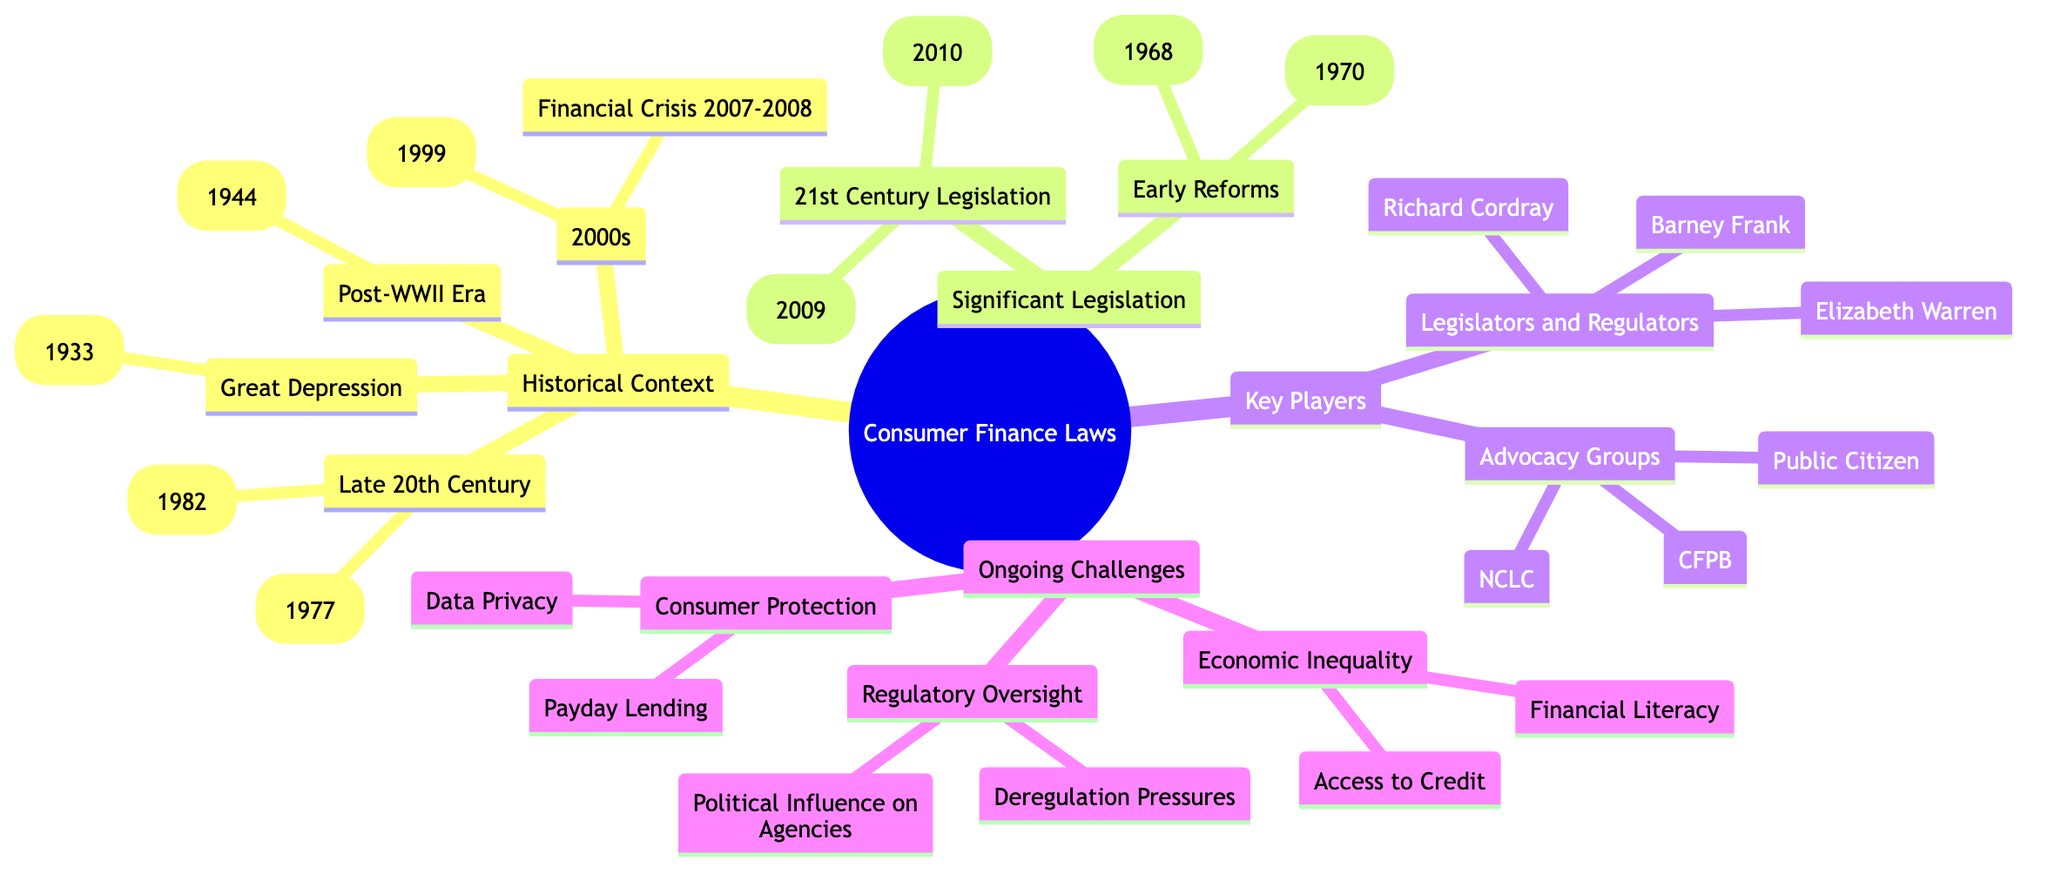What major legislation was established in the Great Depression? According to the diagram's "Historical Context" node, the Glass-Steagall Act (1933) is listed under the Great Depression. Thus, it was a significant piece of legislation from that era.
Answer: Glass-Steagall Act (1933) How many significant pieces of legislation are under the Early Reforms? The "Significant Legislation" section has a sub-node "Early Reforms," which lists two pieces of legislation: the Truth in Lending Act (1968) and the Fair Credit Reporting Act (1970). Hence, there are two in total.
Answer: 2 Which act is associated with payday lending as an ongoing challenge? The "Ongoing Challenges" section highlights consumer protection issues, among which payday lending is specifically mentioned as a challenge. Therefore, payday lending is associated with consumer protection challenges.
Answer: Payday Lending Which act was enacted in 2010? Under the "Major 21st Century Legislation," the Dodd-Frank Wall Street Reform and Consumer Protection Act is listed, which indicates that it was enacted in that year.
Answer: Dodd-Frank Wall Street Reform and Consumer Protection Act (2010) Who are the three advocacy groups listed? The "Key Players" section identifies three advocacy groups: Consumer Financial Protection Bureau (CFPB), Public Citizen, and National Consumer Law Center (NCLC). Thus, these three are the advocacy groups referenced.
Answer: CFPB, Public Citizen, NCLC What legislation corresponds with the Financial Crisis of 2007-2008? The diagram lists the Financial Crisis of 2007-2008 under the "2000s" in the "Historical Context." It does not explicitly state legislation related to it, but the events typically led to significant reforms like the Dodd-Frank Act (2010). Nevertheless, from the information provided, we just correlate it as part of that historical context without specific legislation mentioned in that entry.
Answer: N/A Which legislator is associated with consumer financial protection? Among the legislators and regulators listed in the "Key Players" section, Elizabeth Warren is prominently known for her strong advocacy for consumer financial protection, and she was instrumental in the establishment of the CFPB. Hence, she is associated with this role.
Answer: Elizabeth Warren What ongoing challenge is related to economic inequality? In the "Ongoing Challenges" section, economic inequality is addressed via two aspects: access to credit and financial literacy. Thus, both indicate challenges related to economic inequality.
Answer: Access to Credit, Financial Literacy 